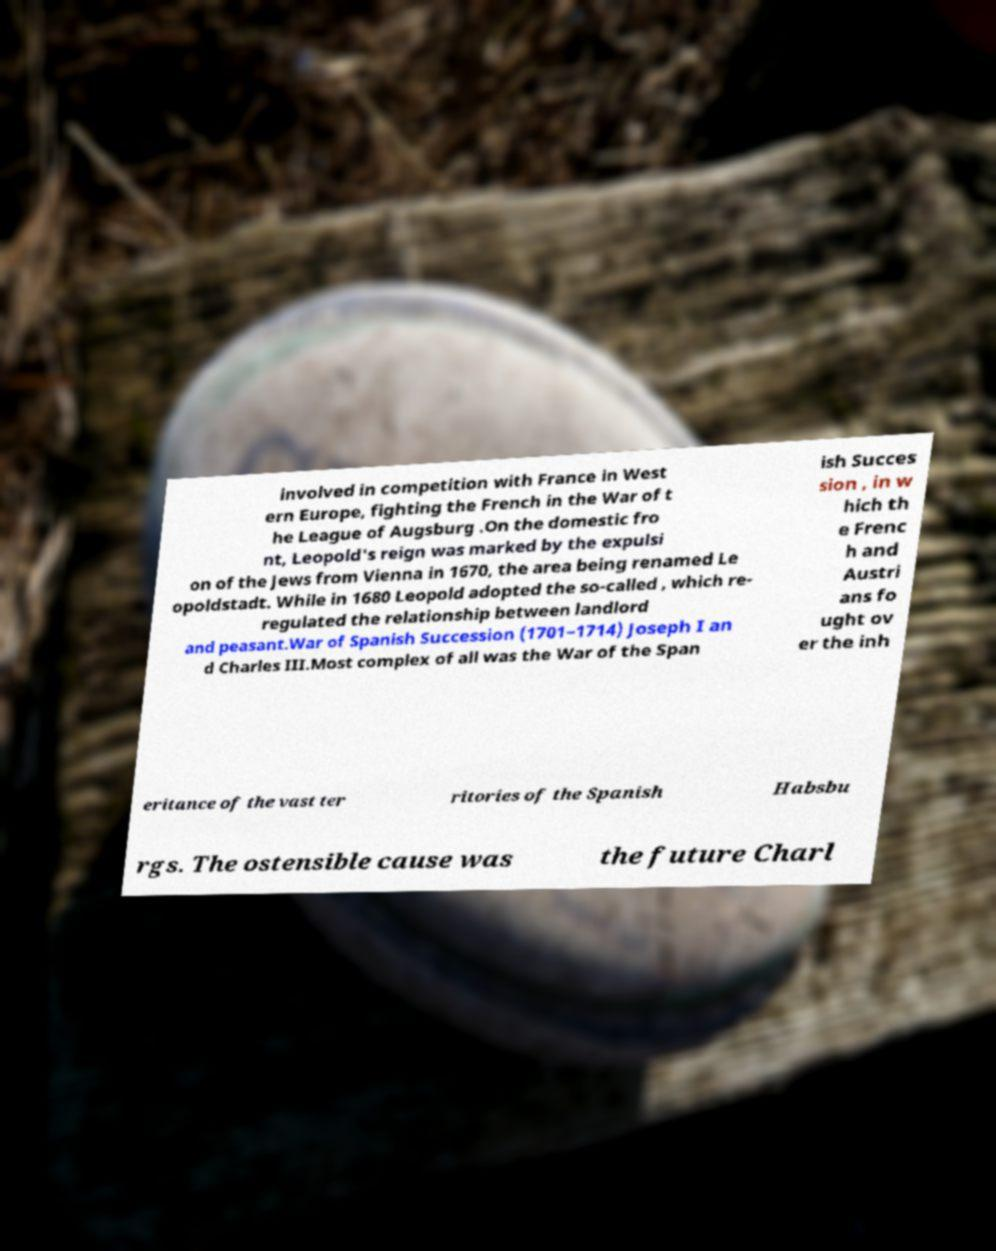Could you assist in decoding the text presented in this image and type it out clearly? involved in competition with France in West ern Europe, fighting the French in the War of t he League of Augsburg .On the domestic fro nt, Leopold's reign was marked by the expulsi on of the Jews from Vienna in 1670, the area being renamed Le opoldstadt. While in 1680 Leopold adopted the so-called , which re- regulated the relationship between landlord and peasant.War of Spanish Succession (1701–1714) Joseph I an d Charles III.Most complex of all was the War of the Span ish Succes sion , in w hich th e Frenc h and Austri ans fo ught ov er the inh eritance of the vast ter ritories of the Spanish Habsbu rgs. The ostensible cause was the future Charl 